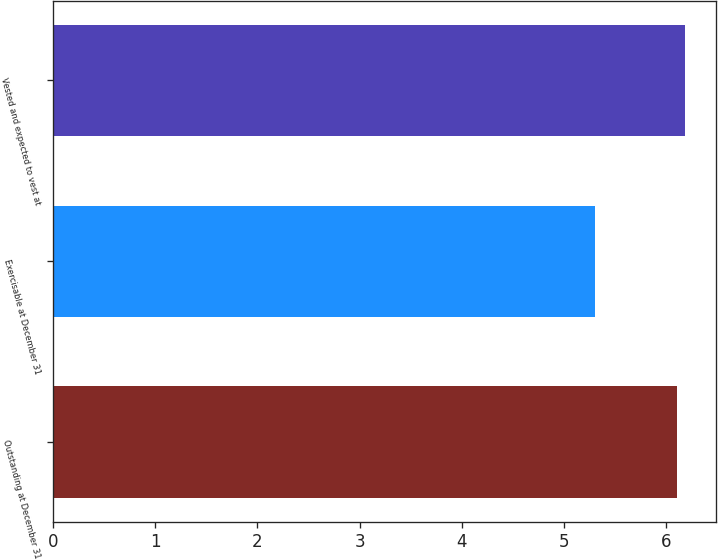<chart> <loc_0><loc_0><loc_500><loc_500><bar_chart><fcel>Outstanding at December 31<fcel>Exercisable at December 31<fcel>Vested and expected to vest at<nl><fcel>6.1<fcel>5.3<fcel>6.18<nl></chart> 